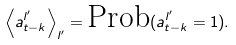<formula> <loc_0><loc_0><loc_500><loc_500>\left < a ^ { l ^ { \prime } } _ { t - k } \right > _ { l ^ { \prime } } = \text {Prob} ( a ^ { l ^ { \prime } } _ { t - k } = 1 ) .</formula> 